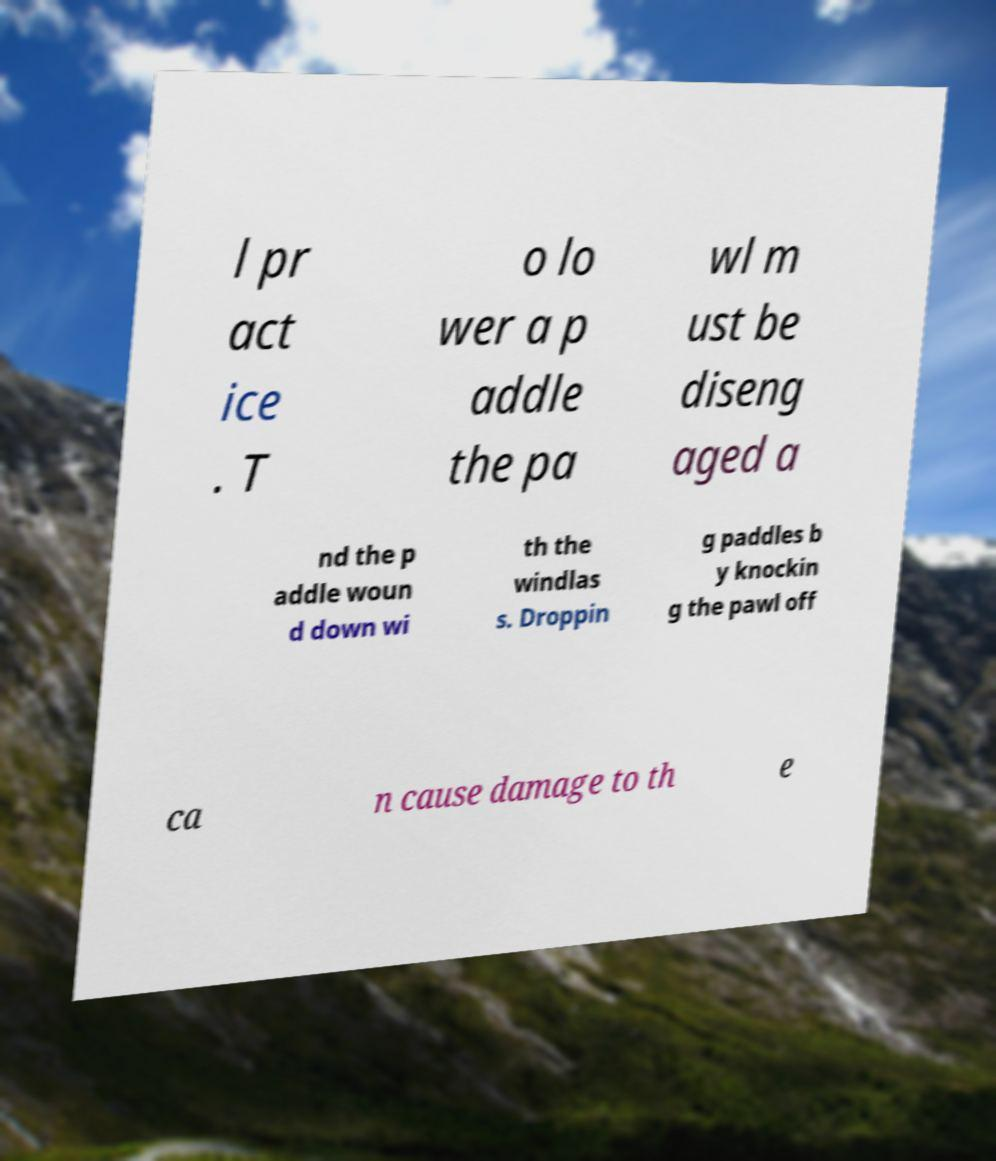Could you assist in decoding the text presented in this image and type it out clearly? l pr act ice . T o lo wer a p addle the pa wl m ust be diseng aged a nd the p addle woun d down wi th the windlas s. Droppin g paddles b y knockin g the pawl off ca n cause damage to th e 